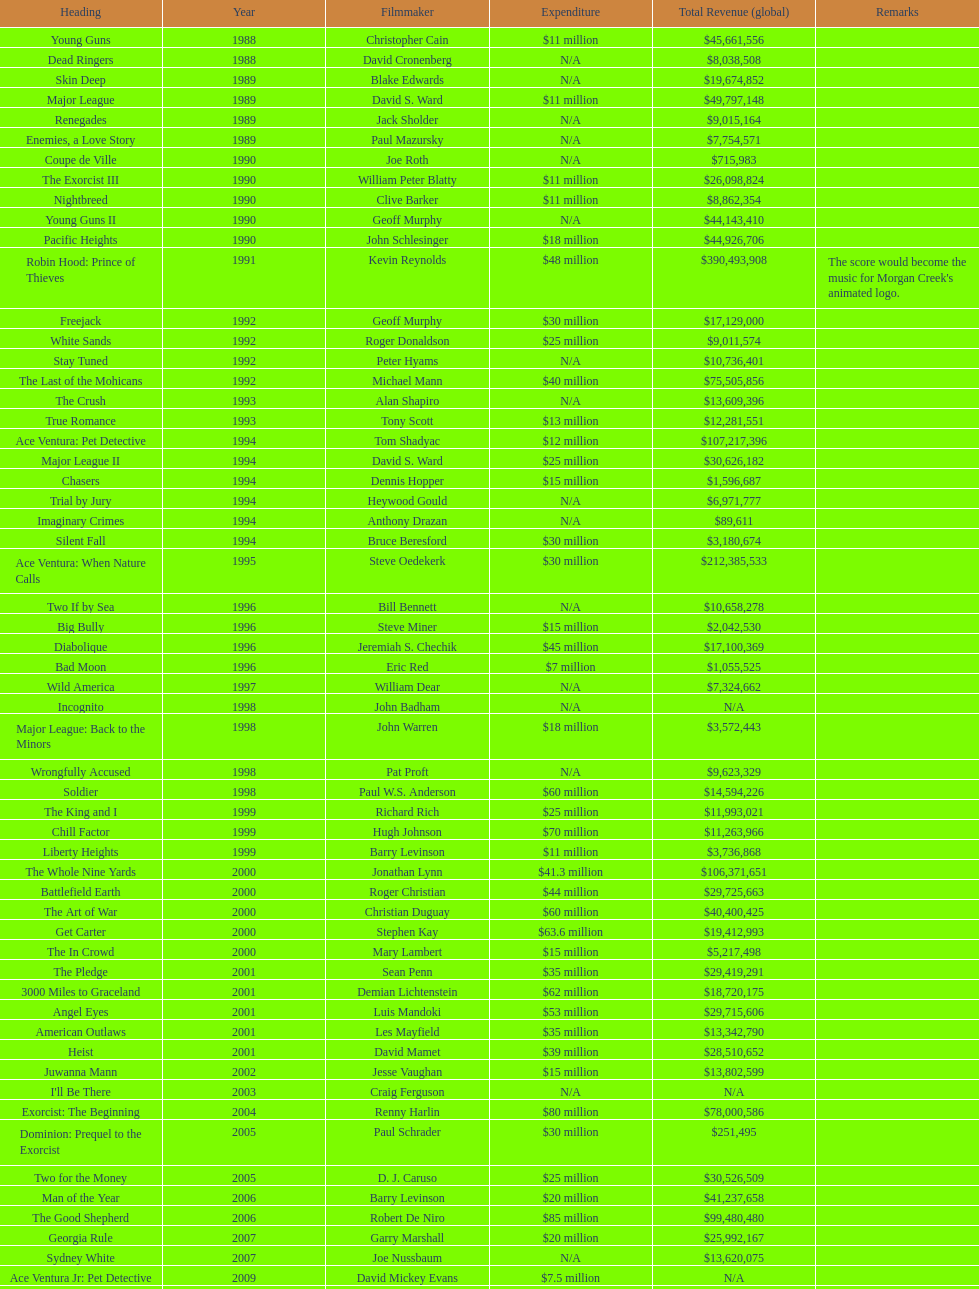What movie came out after bad moon? Wild America. 